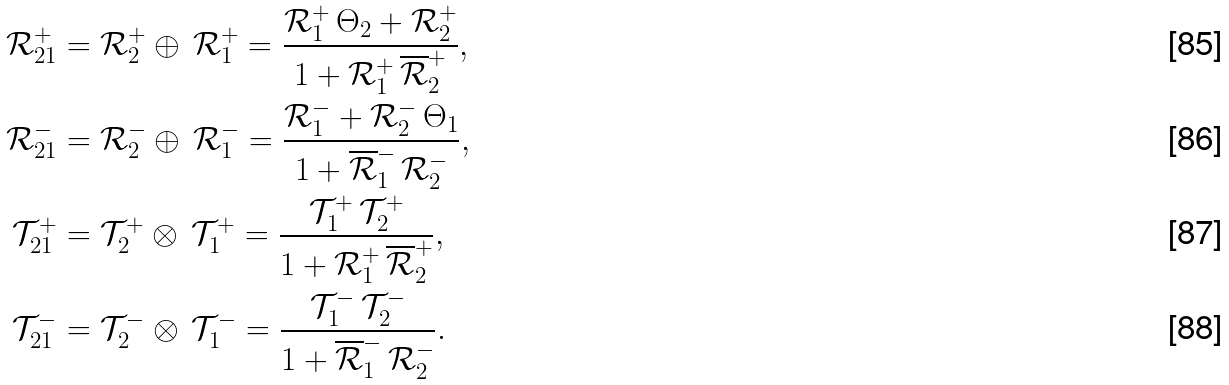<formula> <loc_0><loc_0><loc_500><loc_500>\mathcal { R } ^ { + } _ { 2 1 } & = \mathcal { R } _ { 2 } ^ { + } \oplus \, \mathcal { R } _ { 1 } ^ { + } = \frac { \mathcal { R } _ { 1 } ^ { + } \, \Theta _ { 2 } + \mathcal { R } _ { 2 } ^ { + } } { 1 + \mathcal { R } _ { 1 } ^ { + } \, \overline { \mathcal { R } } _ { 2 } ^ { + } } , \\ \mathcal { R } ^ { - } _ { 2 1 } & = \mathcal { R } _ { 2 } ^ { - } \oplus \, \mathcal { R } _ { 1 } ^ { - } = \frac { \mathcal { R } _ { 1 } ^ { - } + \mathcal { R } _ { 2 } ^ { - } \, \Theta _ { 1 } } { 1 + \overline { \mathcal { R } } _ { 1 } ^ { - } \, \mathcal { R } _ { 2 } ^ { - } } , \\ \mathcal { T } ^ { + } _ { 2 1 } & = \mathcal { T } _ { 2 } ^ { + } \otimes \, \mathcal { T } _ { 1 } ^ { + } = \frac { \mathcal { T } _ { 1 } ^ { + } \, \mathcal { T } _ { 2 } ^ { + } } { 1 + \mathcal { R } _ { 1 } ^ { + } \, \overline { \mathcal { R } } _ { 2 } ^ { + } } , \\ \mathcal { T } ^ { - } _ { 2 1 } & = \mathcal { T } _ { 2 } ^ { - } \otimes \, \mathcal { T } _ { 1 } ^ { - } = \frac { \mathcal { T } _ { 1 } ^ { - } \, \mathcal { T } _ { 2 } ^ { - } } { 1 + \overline { \mathcal { R } } _ { 1 } ^ { - } \, \mathcal { R } _ { 2 } ^ { - } } .</formula> 